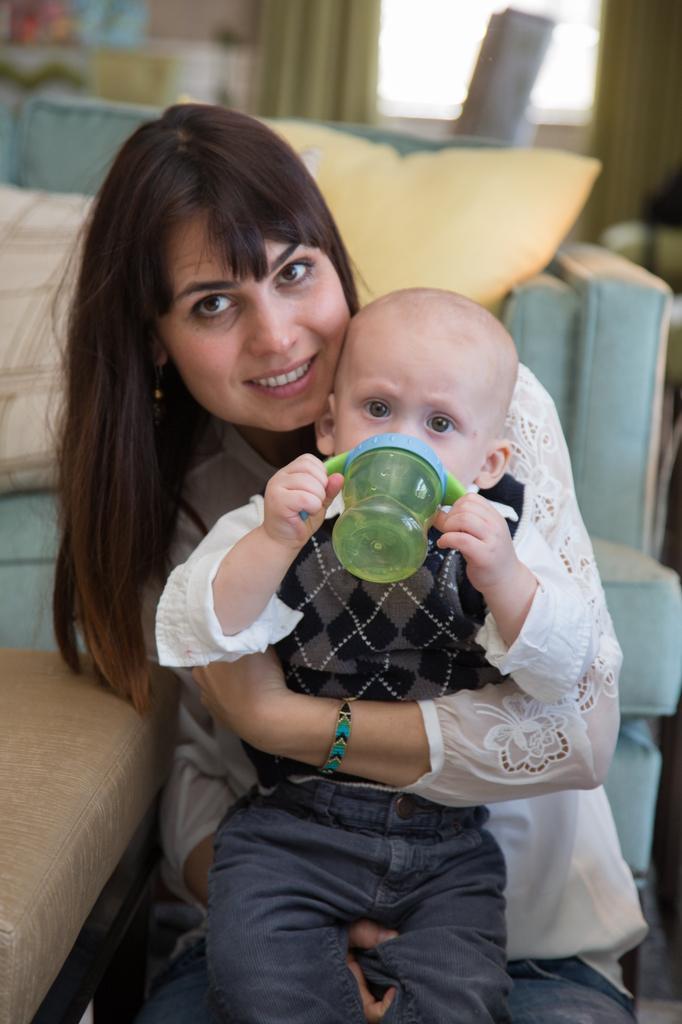In one or two sentences, can you explain what this image depicts? The image is inside the room. In the image there are two people woman and a kid, woman is holding a kid, in background we can see couches,pillows and a door which is closed, curtain in cream color. 